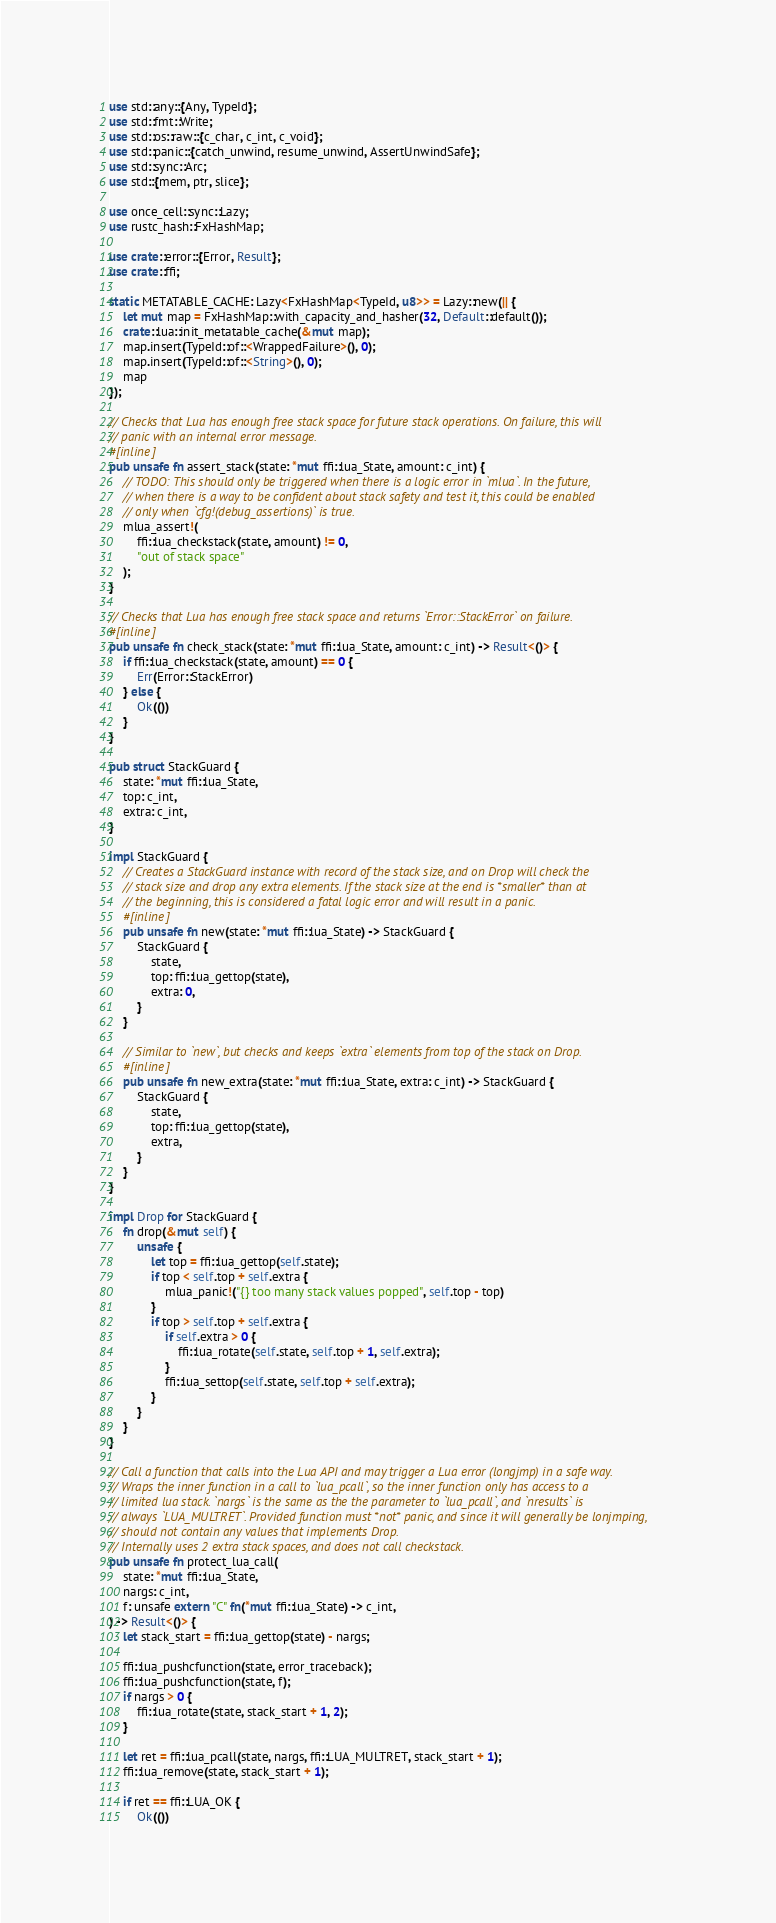Convert code to text. <code><loc_0><loc_0><loc_500><loc_500><_Rust_>use std::any::{Any, TypeId};
use std::fmt::Write;
use std::os::raw::{c_char, c_int, c_void};
use std::panic::{catch_unwind, resume_unwind, AssertUnwindSafe};
use std::sync::Arc;
use std::{mem, ptr, slice};

use once_cell::sync::Lazy;
use rustc_hash::FxHashMap;

use crate::error::{Error, Result};
use crate::ffi;

static METATABLE_CACHE: Lazy<FxHashMap<TypeId, u8>> = Lazy::new(|| {
    let mut map = FxHashMap::with_capacity_and_hasher(32, Default::default());
    crate::lua::init_metatable_cache(&mut map);
    map.insert(TypeId::of::<WrappedFailure>(), 0);
    map.insert(TypeId::of::<String>(), 0);
    map
});

// Checks that Lua has enough free stack space for future stack operations. On failure, this will
// panic with an internal error message.
#[inline]
pub unsafe fn assert_stack(state: *mut ffi::lua_State, amount: c_int) {
    // TODO: This should only be triggered when there is a logic error in `mlua`. In the future,
    // when there is a way to be confident about stack safety and test it, this could be enabled
    // only when `cfg!(debug_assertions)` is true.
    mlua_assert!(
        ffi::lua_checkstack(state, amount) != 0,
        "out of stack space"
    );
}

// Checks that Lua has enough free stack space and returns `Error::StackError` on failure.
#[inline]
pub unsafe fn check_stack(state: *mut ffi::lua_State, amount: c_int) -> Result<()> {
    if ffi::lua_checkstack(state, amount) == 0 {
        Err(Error::StackError)
    } else {
        Ok(())
    }
}

pub struct StackGuard {
    state: *mut ffi::lua_State,
    top: c_int,
    extra: c_int,
}

impl StackGuard {
    // Creates a StackGuard instance with record of the stack size, and on Drop will check the
    // stack size and drop any extra elements. If the stack size at the end is *smaller* than at
    // the beginning, this is considered a fatal logic error and will result in a panic.
    #[inline]
    pub unsafe fn new(state: *mut ffi::lua_State) -> StackGuard {
        StackGuard {
            state,
            top: ffi::lua_gettop(state),
            extra: 0,
        }
    }

    // Similar to `new`, but checks and keeps `extra` elements from top of the stack on Drop.
    #[inline]
    pub unsafe fn new_extra(state: *mut ffi::lua_State, extra: c_int) -> StackGuard {
        StackGuard {
            state,
            top: ffi::lua_gettop(state),
            extra,
        }
    }
}

impl Drop for StackGuard {
    fn drop(&mut self) {
        unsafe {
            let top = ffi::lua_gettop(self.state);
            if top < self.top + self.extra {
                mlua_panic!("{} too many stack values popped", self.top - top)
            }
            if top > self.top + self.extra {
                if self.extra > 0 {
                    ffi::lua_rotate(self.state, self.top + 1, self.extra);
                }
                ffi::lua_settop(self.state, self.top + self.extra);
            }
        }
    }
}

// Call a function that calls into the Lua API and may trigger a Lua error (longjmp) in a safe way.
// Wraps the inner function in a call to `lua_pcall`, so the inner function only has access to a
// limited lua stack. `nargs` is the same as the the parameter to `lua_pcall`, and `nresults` is
// always `LUA_MULTRET`. Provided function must *not* panic, and since it will generally be lonjmping,
// should not contain any values that implements Drop.
// Internally uses 2 extra stack spaces, and does not call checkstack.
pub unsafe fn protect_lua_call(
    state: *mut ffi::lua_State,
    nargs: c_int,
    f: unsafe extern "C" fn(*mut ffi::lua_State) -> c_int,
) -> Result<()> {
    let stack_start = ffi::lua_gettop(state) - nargs;

    ffi::lua_pushcfunction(state, error_traceback);
    ffi::lua_pushcfunction(state, f);
    if nargs > 0 {
        ffi::lua_rotate(state, stack_start + 1, 2);
    }

    let ret = ffi::lua_pcall(state, nargs, ffi::LUA_MULTRET, stack_start + 1);
    ffi::lua_remove(state, stack_start + 1);

    if ret == ffi::LUA_OK {
        Ok(())</code> 